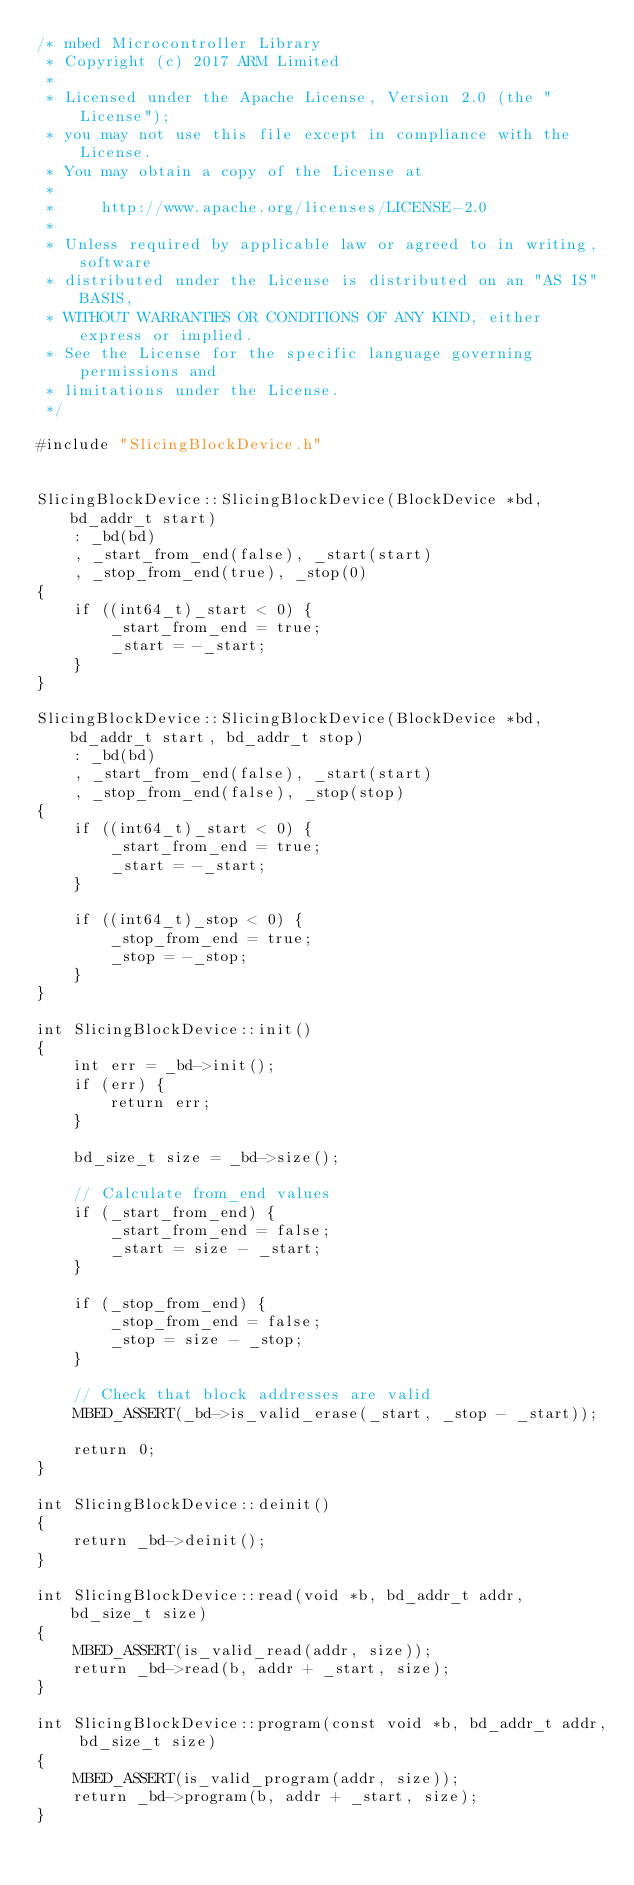Convert code to text. <code><loc_0><loc_0><loc_500><loc_500><_C++_>/* mbed Microcontroller Library
 * Copyright (c) 2017 ARM Limited
 *
 * Licensed under the Apache License, Version 2.0 (the "License");
 * you may not use this file except in compliance with the License.
 * You may obtain a copy of the License at
 *
 *     http://www.apache.org/licenses/LICENSE-2.0
 *
 * Unless required by applicable law or agreed to in writing, software
 * distributed under the License is distributed on an "AS IS" BASIS,
 * WITHOUT WARRANTIES OR CONDITIONS OF ANY KIND, either express or implied.
 * See the License for the specific language governing permissions and
 * limitations under the License.
 */

#include "SlicingBlockDevice.h"


SlicingBlockDevice::SlicingBlockDevice(BlockDevice *bd, bd_addr_t start)
    : _bd(bd)
    , _start_from_end(false), _start(start)
    , _stop_from_end(true), _stop(0)
{
    if ((int64_t)_start < 0) {
        _start_from_end = true;
        _start = -_start;
    }
}

SlicingBlockDevice::SlicingBlockDevice(BlockDevice *bd, bd_addr_t start, bd_addr_t stop)
    : _bd(bd)
    , _start_from_end(false), _start(start)
    , _stop_from_end(false), _stop(stop)
{
    if ((int64_t)_start < 0) {
        _start_from_end = true;
        _start = -_start;
    }

    if ((int64_t)_stop < 0) {
        _stop_from_end = true;
        _stop = -_stop;
    }
}

int SlicingBlockDevice::init()
{
    int err = _bd->init();
    if (err) {
        return err;
    }

    bd_size_t size = _bd->size();

    // Calculate from_end values
    if (_start_from_end) {
        _start_from_end = false;
        _start = size - _start;
    }

    if (_stop_from_end) {
        _stop_from_end = false;
        _stop = size - _stop;
    }

    // Check that block addresses are valid
    MBED_ASSERT(_bd->is_valid_erase(_start, _stop - _start));

    return 0;
}

int SlicingBlockDevice::deinit()
{
    return _bd->deinit();
}

int SlicingBlockDevice::read(void *b, bd_addr_t addr, bd_size_t size)
{
    MBED_ASSERT(is_valid_read(addr, size));
    return _bd->read(b, addr + _start, size);
}

int SlicingBlockDevice::program(const void *b, bd_addr_t addr, bd_size_t size)
{
    MBED_ASSERT(is_valid_program(addr, size));
    return _bd->program(b, addr + _start, size);
}
</code> 